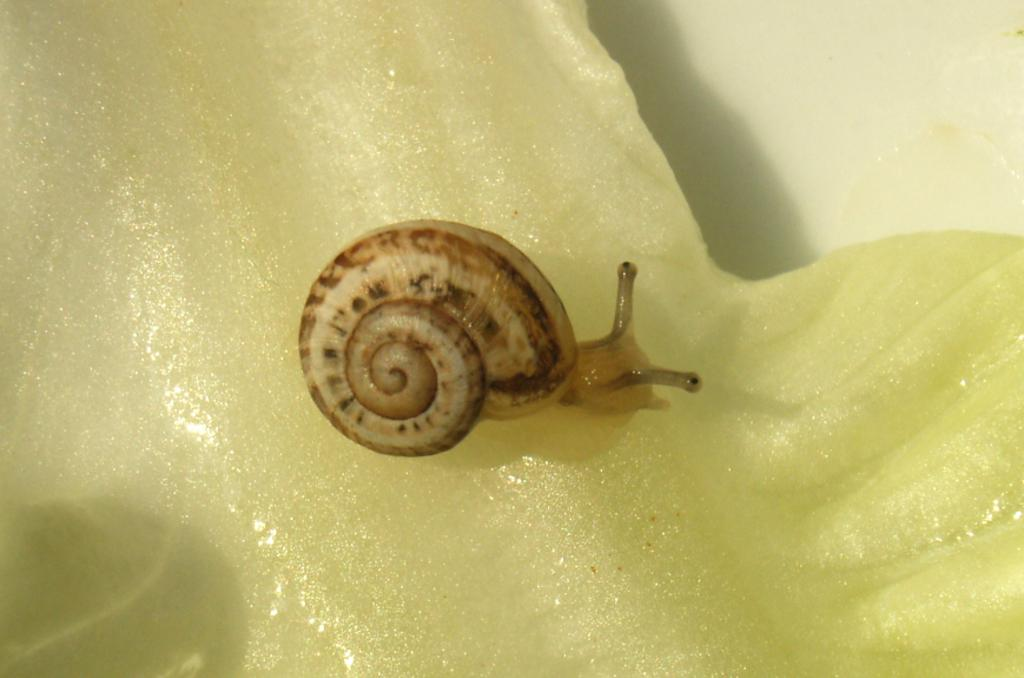What is the main subject of the image? There is a snail in the image. Where is the snail located in the image? The snail is in the middle of the image. What type of cushion is the snail sitting on in the image? There is no cushion present in the image; the snail is not sitting on anything. How many apples can be seen in the image? There are no apples present in the image. 